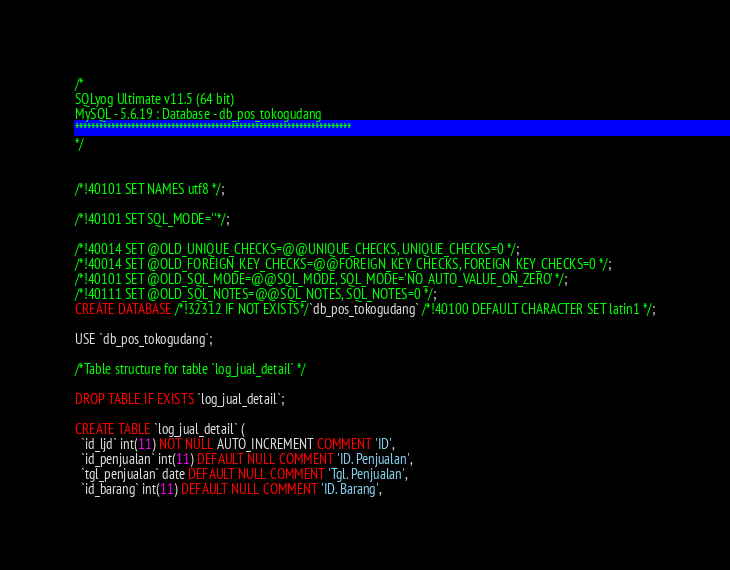Convert code to text. <code><loc_0><loc_0><loc_500><loc_500><_SQL_>/*
SQLyog Ultimate v11.5 (64 bit)
MySQL - 5.6.19 : Database - db_pos_tokogudang
*********************************************************************
*/

/*!40101 SET NAMES utf8 */;

/*!40101 SET SQL_MODE=''*/;

/*!40014 SET @OLD_UNIQUE_CHECKS=@@UNIQUE_CHECKS, UNIQUE_CHECKS=0 */;
/*!40014 SET @OLD_FOREIGN_KEY_CHECKS=@@FOREIGN_KEY_CHECKS, FOREIGN_KEY_CHECKS=0 */;
/*!40101 SET @OLD_SQL_MODE=@@SQL_MODE, SQL_MODE='NO_AUTO_VALUE_ON_ZERO' */;
/*!40111 SET @OLD_SQL_NOTES=@@SQL_NOTES, SQL_NOTES=0 */;
CREATE DATABASE /*!32312 IF NOT EXISTS*/`db_pos_tokogudang` /*!40100 DEFAULT CHARACTER SET latin1 */;

USE `db_pos_tokogudang`;

/*Table structure for table `log_jual_detail` */

DROP TABLE IF EXISTS `log_jual_detail`;

CREATE TABLE `log_jual_detail` (
  `id_ljd` int(11) NOT NULL AUTO_INCREMENT COMMENT 'ID',
  `id_penjualan` int(11) DEFAULT NULL COMMENT 'ID. Penjualan',
  `tgl_penjualan` date DEFAULT NULL COMMENT 'Tgl. Penjualan',
  `id_barang` int(11) DEFAULT NULL COMMENT 'ID. Barang',</code> 